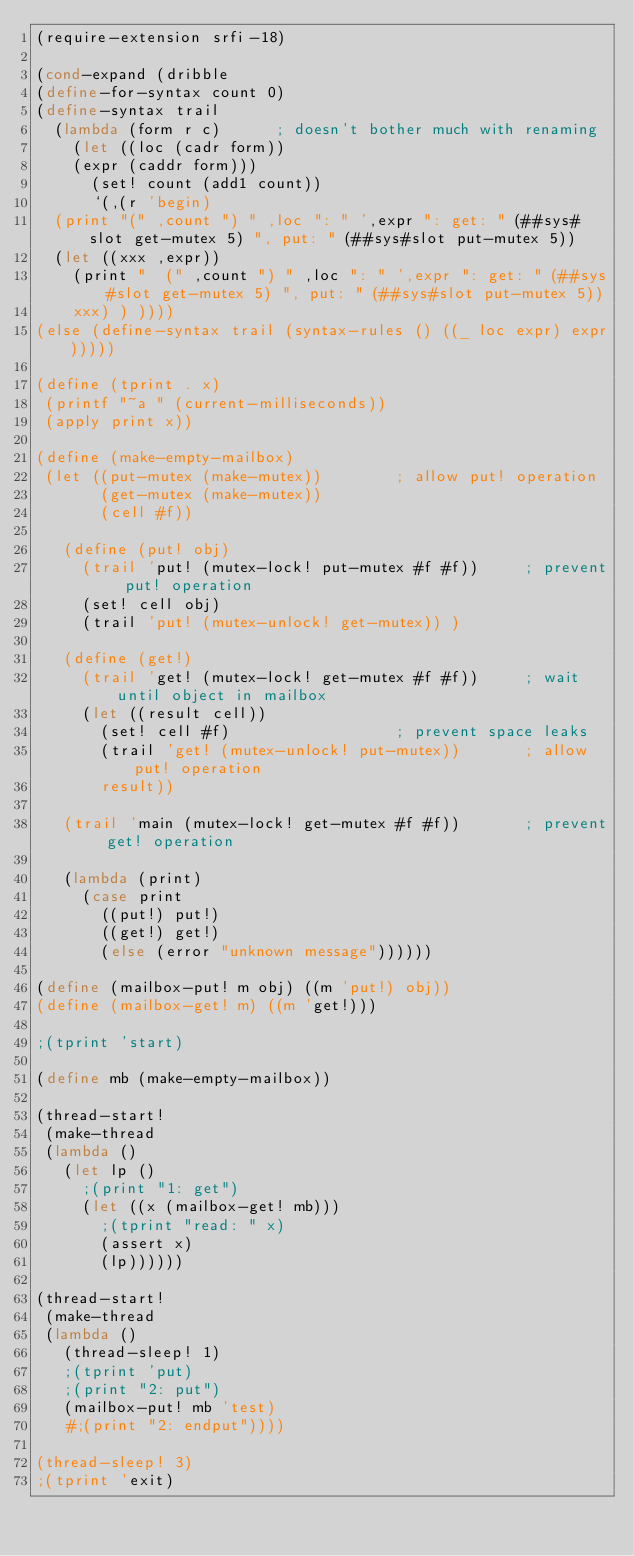<code> <loc_0><loc_0><loc_500><loc_500><_Scheme_>(require-extension srfi-18)

(cond-expand (dribble
(define-for-syntax count 0)
(define-syntax trail
  (lambda (form r c)			; doesn't bother much with renaming
    (let ((loc (cadr form))
	  (expr (caddr form)))
      (set! count (add1 count))
      `(,(r 'begin)
	(print "(" ,count ") " ,loc ": " ',expr ": get: " (##sys#slot get-mutex 5) ", put: " (##sys#slot put-mutex 5))
	(let ((xxx ,expr))
	  (print "  (" ,count ") " ,loc ": " ',expr ": get: " (##sys#slot get-mutex 5) ", put: " (##sys#slot put-mutex 5))
	  xxx) ) ))))
(else (define-syntax trail (syntax-rules () ((_ loc expr) expr)))))

(define (tprint . x)
 (printf "~a " (current-milliseconds))
 (apply print x))

(define (make-empty-mailbox)
 (let ((put-mutex (make-mutex))        ; allow put! operation
       (get-mutex (make-mutex))
       (cell #f))

   (define (put! obj)
     (trail 'put! (mutex-lock! put-mutex #f #f))     ; prevent put! operation
     (set! cell obj)
     (trail 'put! (mutex-unlock! get-mutex)) )

   (define (get!)
     (trail 'get! (mutex-lock! get-mutex #f #f))     ; wait until object in mailbox
     (let ((result cell))
       (set! cell #f)                  ; prevent space leaks
       (trail 'get! (mutex-unlock! put-mutex))       ; allow put! operation
       result))

   (trail 'main (mutex-lock! get-mutex #f #f))       ; prevent get! operation

   (lambda (print)
     (case print
       ((put!) put!)
       ((get!) get!)
       (else (error "unknown message"))))))

(define (mailbox-put! m obj) ((m 'put!) obj))
(define (mailbox-get! m) ((m 'get!)))

;(tprint 'start)

(define mb (make-empty-mailbox))

(thread-start!
 (make-thread
 (lambda ()
   (let lp ()
     ;(print "1: get")
     (let ((x (mailbox-get! mb)))
       ;(tprint "read: " x)
       (assert x)
       (lp))))))

(thread-start!
 (make-thread
 (lambda ()
   (thread-sleep! 1)
   ;(tprint 'put)
   ;(print "2: put")
   (mailbox-put! mb 'test)
   #;(print "2: endput"))))

(thread-sleep! 3)
;(tprint 'exit)
</code> 